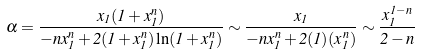Convert formula to latex. <formula><loc_0><loc_0><loc_500><loc_500>\alpha = \frac { x _ { 1 } ( 1 + x _ { 1 } ^ { n } ) } { - n x _ { 1 } ^ { n } + 2 ( 1 + x _ { 1 } ^ { n } ) \ln ( 1 + x _ { 1 } ^ { n } ) } \sim \frac { x _ { 1 } } { - n x _ { 1 } ^ { n } + 2 ( 1 ) ( x _ { 1 } ^ { n } ) } \sim \frac { x _ { 1 } ^ { 1 - n } } { 2 - n }</formula> 